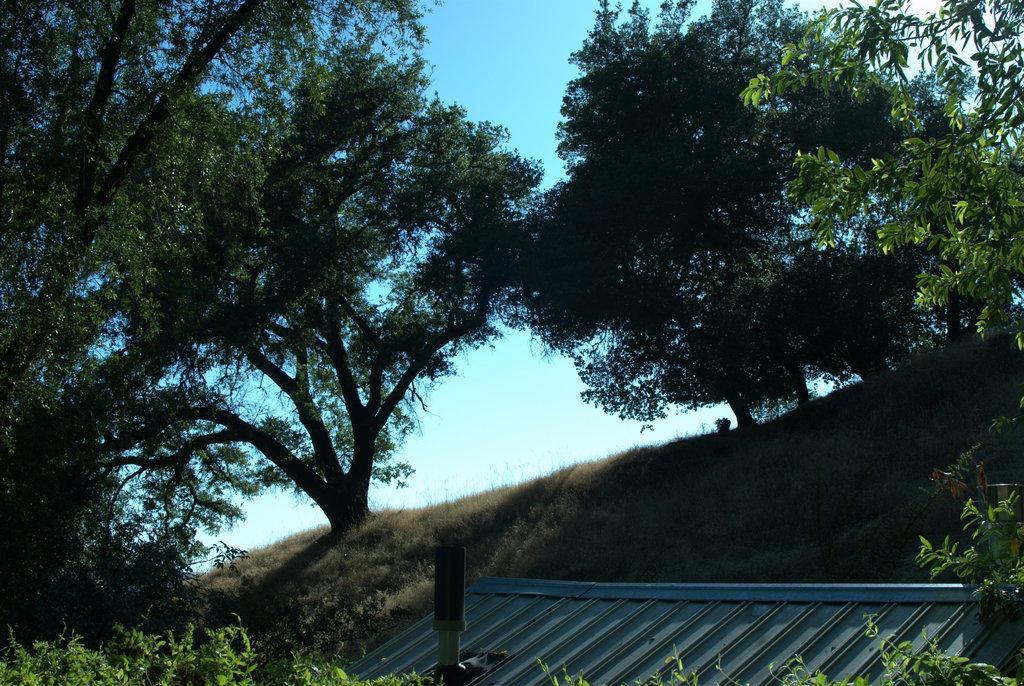Please provide a concise description of this image. In this picture I can see the trees, plants and grass. At the bottom I can see the roof of the shed. At the top I can see the sky. 